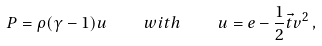Convert formula to latex. <formula><loc_0><loc_0><loc_500><loc_500>P = \rho ( \gamma - 1 ) u \quad w i t h \quad u = e - \frac { 1 } { 2 } \vec { t } { v } ^ { 2 } \, ,</formula> 